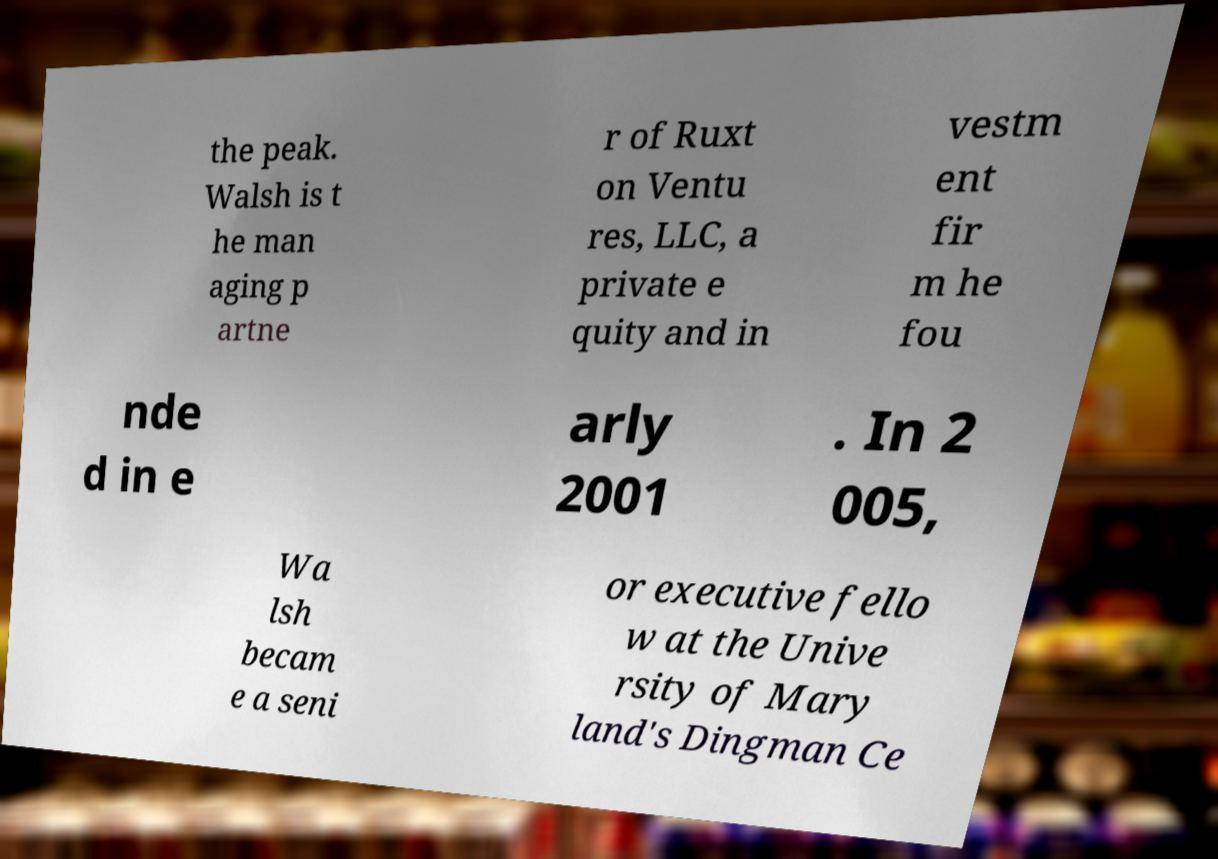Please read and relay the text visible in this image. What does it say? the peak. Walsh is t he man aging p artne r of Ruxt on Ventu res, LLC, a private e quity and in vestm ent fir m he fou nde d in e arly 2001 . In 2 005, Wa lsh becam e a seni or executive fello w at the Unive rsity of Mary land's Dingman Ce 